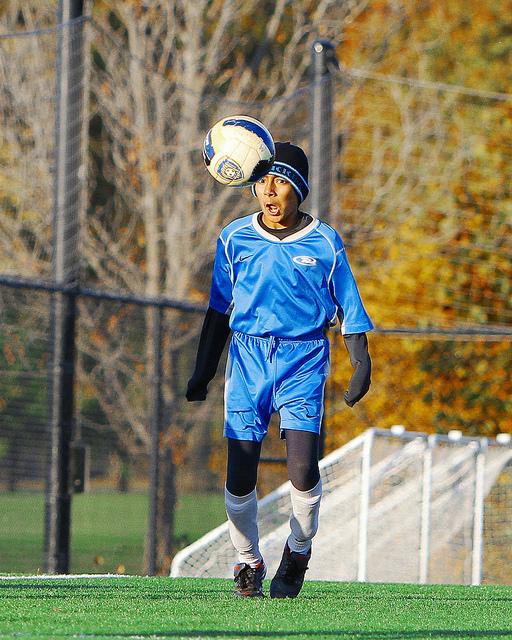Where are the guy's hands?
Keep it brief. In his sleeves. Is the guy skateboarding?
Concise answer only. No. What is on his ears?
Give a very brief answer. Hat. What color is the band on his left wrist?
Short answer required. Black. What kind of goal is this?
Write a very short answer. Soccer. What color is his uniform?
Quick response, please. Blue. Is the kid wearing a helmet?
Short answer required. No. 